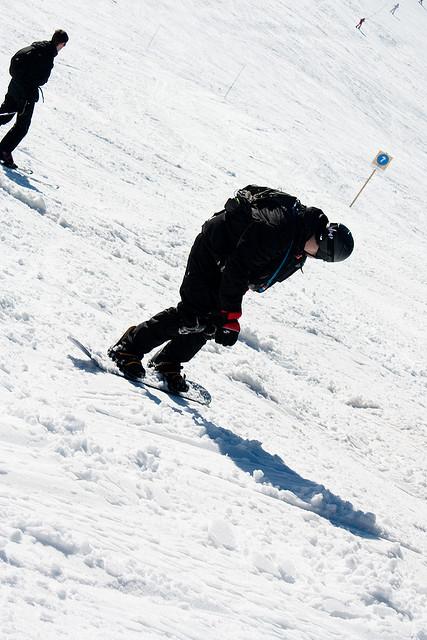What is this man wearing on his hands?
Write a very short answer. Gloves. What sport is this man performing?
Concise answer only. Snowboarding. Is the sun in the sky?
Be succinct. Yes. 